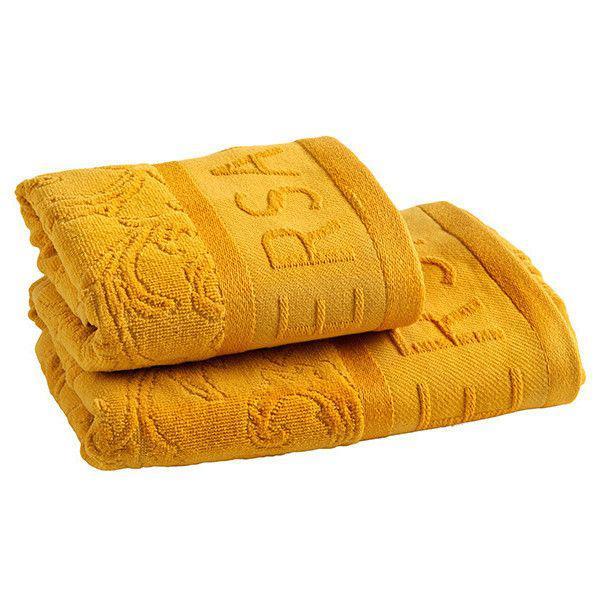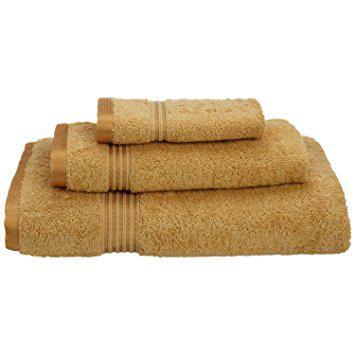The first image is the image on the left, the second image is the image on the right. Assess this claim about the two images: "more than 3 stacks of colorful towels". Correct or not? Answer yes or no. No. The first image is the image on the left, the second image is the image on the right. Evaluate the accuracy of this statement regarding the images: "There is a stack of at least five different colored towels.". Is it true? Answer yes or no. No. 